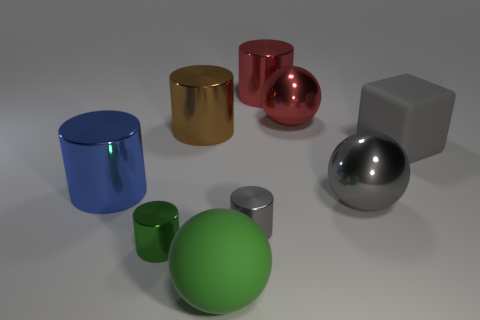What number of other things are made of the same material as the large brown thing?
Offer a terse response. 6. There is a red object to the left of the red sphere; does it have the same shape as the small gray metal thing?
Provide a short and direct response. Yes. What number of big things are metal things or balls?
Your answer should be very brief. 6. Is the number of gray objects that are on the left side of the large brown thing the same as the number of green things on the left side of the big blue metallic cylinder?
Your answer should be very brief. Yes. How many other objects are the same color as the matte ball?
Provide a short and direct response. 1. Is the color of the big cube the same as the tiny metallic cylinder on the right side of the green rubber ball?
Your answer should be very brief. Yes. How many green objects are tiny shiny cylinders or big cylinders?
Offer a very short reply. 1. Are there an equal number of small gray metallic cylinders in front of the gray block and green matte spheres?
Your answer should be very brief. Yes. What color is the rubber object that is the same shape as the large gray metal object?
Provide a succinct answer. Green. How many large yellow objects are the same shape as the blue metal object?
Ensure brevity in your answer.  0. 